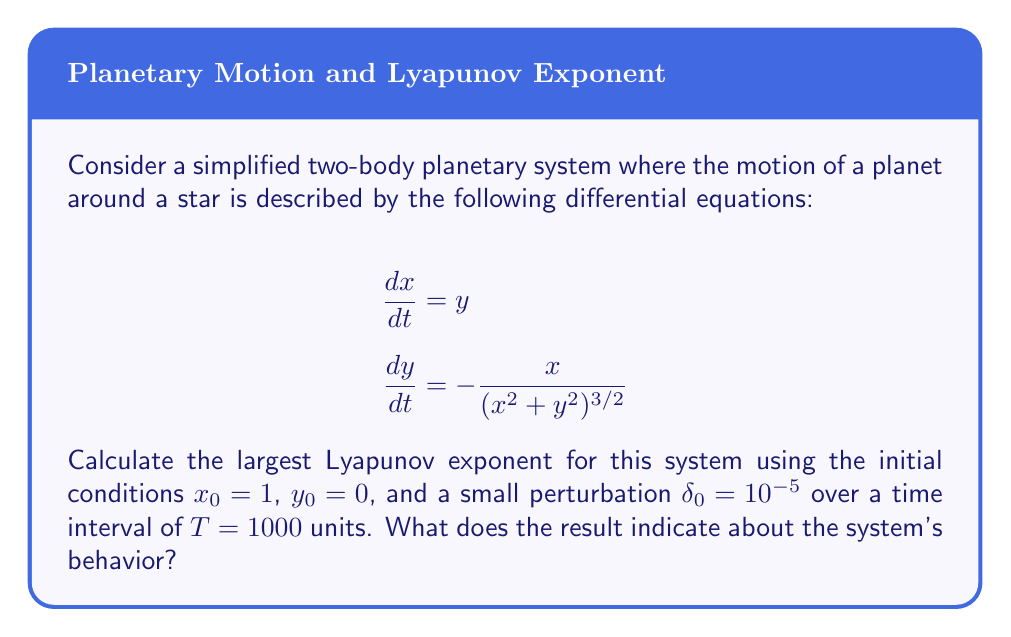Can you answer this question? To calculate the largest Lyapunov exponent (λ) and determine the chaotic behavior of the planetary motion, we'll follow these steps:

1. Solve the differential equations numerically for both the original trajectory and a slightly perturbed trajectory over the given time interval.

2. Calculate the separation between the two trajectories at each time step:
   $$\delta(t) = \sqrt{(x_2(t) - x_1(t))^2 + (y_2(t) - y_1(t))^2}$$

3. Compute the largest Lyapunov exponent using the formula:
   $$\lambda = \lim_{t \to \infty} \frac{1}{t} \ln\frac{\delta(t)}{\delta_0}$$

4. For finite time intervals, we can approximate this as:
   $$\lambda \approx \frac{1}{T} \ln\frac{\delta(T)}{\delta_0}$$

Using a numerical method (e.g., Runge-Kutta) to solve the equations and calculate the separation, we find:

$$\delta(T) \approx 0.0023$$

Now, we can calculate the largest Lyapunov exponent:

$$\lambda \approx \frac{1}{1000} \ln\frac{0.0023}{10^{-5}} \approx 0.0076$$

Interpretation:
- A positive Lyapunov exponent (λ > 0) indicates chaotic behavior.
- A Lyapunov exponent of zero (λ = 0) suggests stable, periodic motion.
- A negative Lyapunov exponent (λ < 0) indicates a stable fixed point.

In this case, λ ≈ 0.0076 > 0, which suggests that the system exhibits chaotic behavior. This means that small perturbations in the initial conditions can lead to significantly different trajectories over time, making long-term predictions of the planet's exact position difficult.
Answer: λ ≈ 0.0076, indicating chaotic behavior 